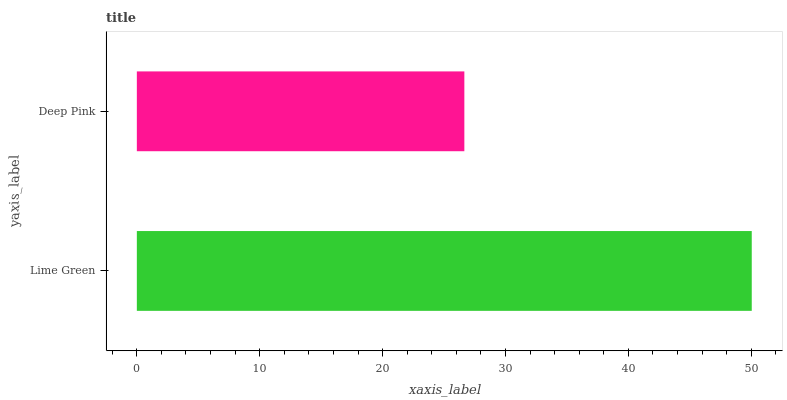Is Deep Pink the minimum?
Answer yes or no. Yes. Is Lime Green the maximum?
Answer yes or no. Yes. Is Deep Pink the maximum?
Answer yes or no. No. Is Lime Green greater than Deep Pink?
Answer yes or no. Yes. Is Deep Pink less than Lime Green?
Answer yes or no. Yes. Is Deep Pink greater than Lime Green?
Answer yes or no. No. Is Lime Green less than Deep Pink?
Answer yes or no. No. Is Lime Green the high median?
Answer yes or no. Yes. Is Deep Pink the low median?
Answer yes or no. Yes. Is Deep Pink the high median?
Answer yes or no. No. Is Lime Green the low median?
Answer yes or no. No. 